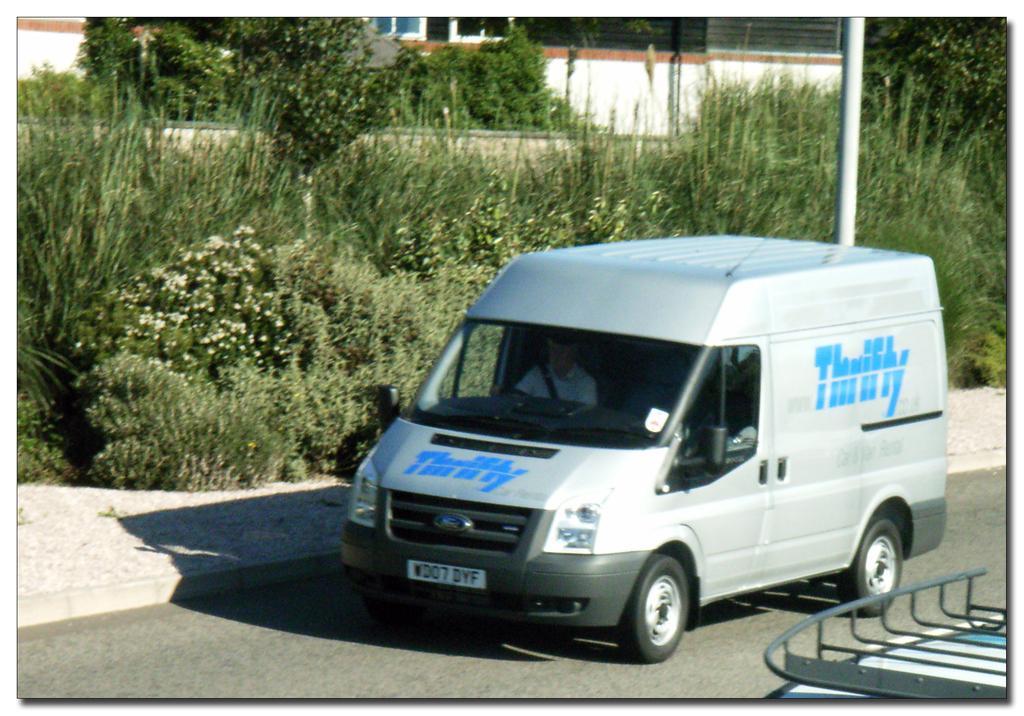Describe this image in one or two sentences. In this picture I can see few plants and a vehicle in the middle, there is a pole on the right side. In the bottom right hand side there is an iron grill, at the top there are buildings and trees. 